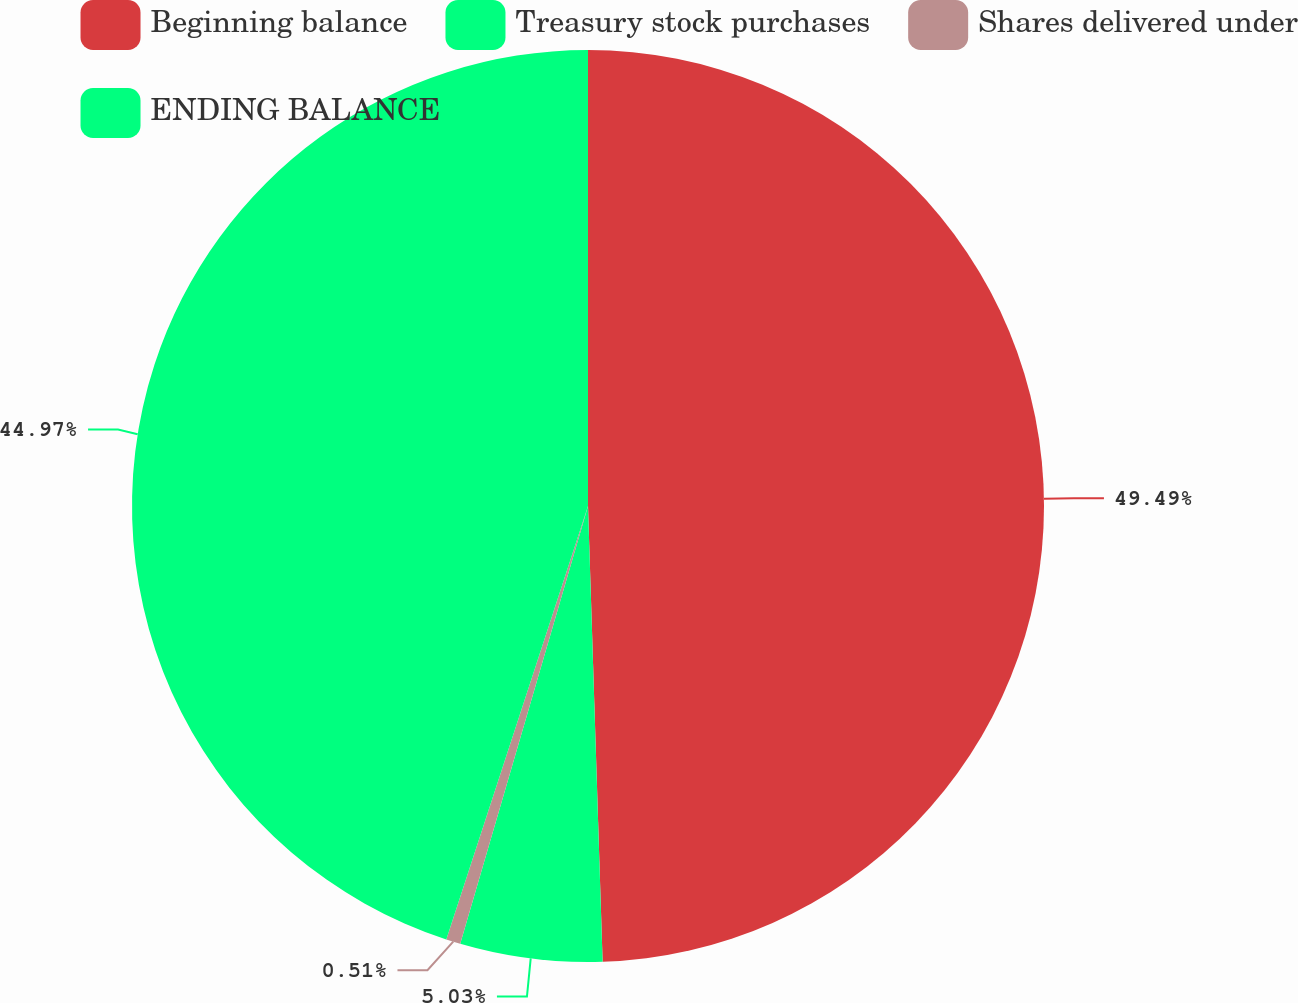Convert chart to OTSL. <chart><loc_0><loc_0><loc_500><loc_500><pie_chart><fcel>Beginning balance<fcel>Treasury stock purchases<fcel>Shares delivered under<fcel>ENDING BALANCE<nl><fcel>49.49%<fcel>5.03%<fcel>0.51%<fcel>44.97%<nl></chart> 